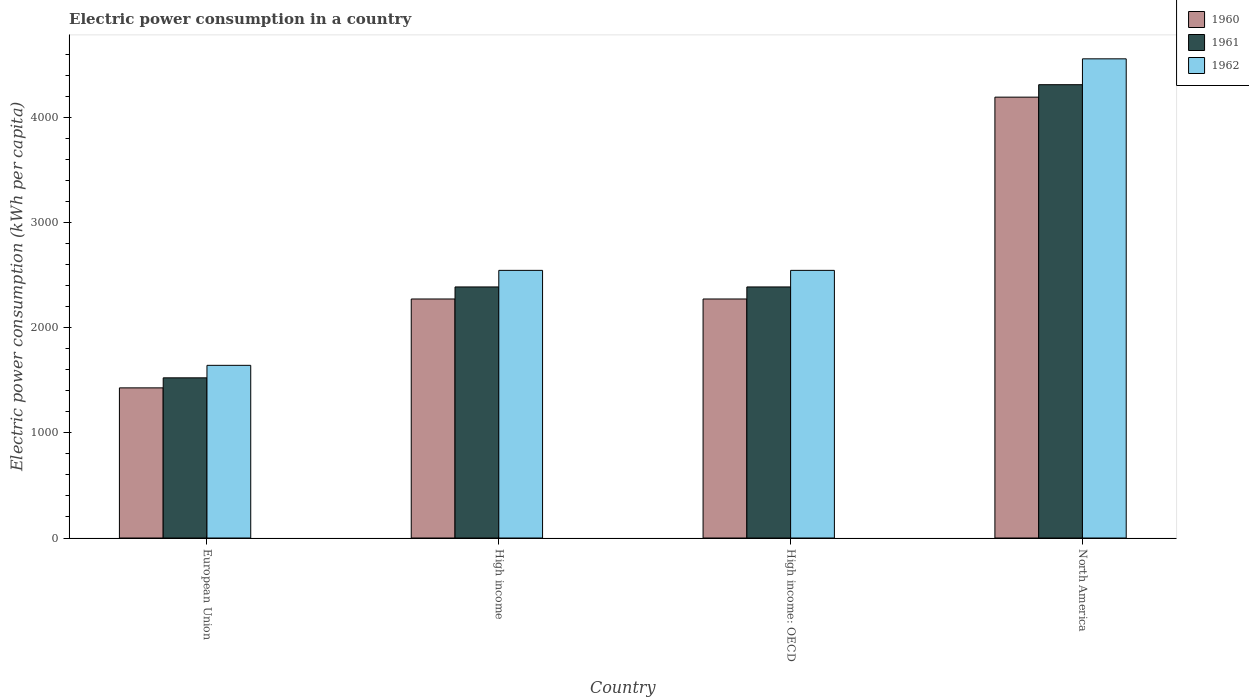Are the number of bars per tick equal to the number of legend labels?
Offer a terse response. Yes. What is the label of the 3rd group of bars from the left?
Provide a succinct answer. High income: OECD. In how many cases, is the number of bars for a given country not equal to the number of legend labels?
Provide a short and direct response. 0. What is the electric power consumption in in 1962 in European Union?
Give a very brief answer. 1641.97. Across all countries, what is the maximum electric power consumption in in 1962?
Your answer should be compact. 4556.78. Across all countries, what is the minimum electric power consumption in in 1960?
Give a very brief answer. 1427.78. In which country was the electric power consumption in in 1962 minimum?
Make the answer very short. European Union. What is the total electric power consumption in in 1961 in the graph?
Your answer should be compact. 1.06e+04. What is the difference between the electric power consumption in in 1962 in High income and that in High income: OECD?
Your answer should be compact. 0. What is the difference between the electric power consumption in in 1961 in North America and the electric power consumption in in 1962 in High income: OECD?
Provide a short and direct response. 1765.67. What is the average electric power consumption in in 1962 per country?
Make the answer very short. 2822.3. What is the difference between the electric power consumption in of/in 1961 and electric power consumption in of/in 1960 in North America?
Your answer should be very brief. 118.55. In how many countries, is the electric power consumption in in 1961 greater than 600 kWh per capita?
Give a very brief answer. 4. What is the ratio of the electric power consumption in in 1960 in European Union to that in North America?
Make the answer very short. 0.34. Is the difference between the electric power consumption in in 1961 in High income: OECD and North America greater than the difference between the electric power consumption in in 1960 in High income: OECD and North America?
Provide a short and direct response. No. What is the difference between the highest and the second highest electric power consumption in in 1962?
Offer a terse response. -2011.55. What is the difference between the highest and the lowest electric power consumption in in 1962?
Ensure brevity in your answer.  2914.81. In how many countries, is the electric power consumption in in 1960 greater than the average electric power consumption in in 1960 taken over all countries?
Your answer should be very brief. 1. Is the sum of the electric power consumption in in 1961 in High income: OECD and North America greater than the maximum electric power consumption in in 1960 across all countries?
Offer a very short reply. Yes. What does the 3rd bar from the left in European Union represents?
Provide a succinct answer. 1962. Is it the case that in every country, the sum of the electric power consumption in in 1962 and electric power consumption in in 1960 is greater than the electric power consumption in in 1961?
Offer a terse response. Yes. Are all the bars in the graph horizontal?
Offer a terse response. No. Does the graph contain any zero values?
Keep it short and to the point. No. Where does the legend appear in the graph?
Offer a very short reply. Top right. How are the legend labels stacked?
Your response must be concise. Vertical. What is the title of the graph?
Offer a terse response. Electric power consumption in a country. Does "1969" appear as one of the legend labels in the graph?
Keep it short and to the point. No. What is the label or title of the Y-axis?
Your answer should be compact. Electric power consumption (kWh per capita). What is the Electric power consumption (kWh per capita) in 1960 in European Union?
Your response must be concise. 1427.78. What is the Electric power consumption (kWh per capita) of 1961 in European Union?
Keep it short and to the point. 1523.15. What is the Electric power consumption (kWh per capita) of 1962 in European Union?
Provide a succinct answer. 1641.97. What is the Electric power consumption (kWh per capita) in 1960 in High income?
Offer a terse response. 2272.98. What is the Electric power consumption (kWh per capita) of 1961 in High income?
Give a very brief answer. 2387.51. What is the Electric power consumption (kWh per capita) in 1962 in High income?
Your answer should be compact. 2545.23. What is the Electric power consumption (kWh per capita) in 1960 in High income: OECD?
Make the answer very short. 2272.98. What is the Electric power consumption (kWh per capita) in 1961 in High income: OECD?
Your response must be concise. 2387.51. What is the Electric power consumption (kWh per capita) of 1962 in High income: OECD?
Keep it short and to the point. 2545.23. What is the Electric power consumption (kWh per capita) in 1960 in North America?
Offer a terse response. 4192.36. What is the Electric power consumption (kWh per capita) of 1961 in North America?
Provide a short and direct response. 4310.91. What is the Electric power consumption (kWh per capita) of 1962 in North America?
Offer a terse response. 4556.78. Across all countries, what is the maximum Electric power consumption (kWh per capita) in 1960?
Keep it short and to the point. 4192.36. Across all countries, what is the maximum Electric power consumption (kWh per capita) of 1961?
Provide a succinct answer. 4310.91. Across all countries, what is the maximum Electric power consumption (kWh per capita) of 1962?
Offer a terse response. 4556.78. Across all countries, what is the minimum Electric power consumption (kWh per capita) in 1960?
Offer a very short reply. 1427.78. Across all countries, what is the minimum Electric power consumption (kWh per capita) in 1961?
Provide a short and direct response. 1523.15. Across all countries, what is the minimum Electric power consumption (kWh per capita) of 1962?
Offer a terse response. 1641.97. What is the total Electric power consumption (kWh per capita) of 1960 in the graph?
Keep it short and to the point. 1.02e+04. What is the total Electric power consumption (kWh per capita) of 1961 in the graph?
Make the answer very short. 1.06e+04. What is the total Electric power consumption (kWh per capita) of 1962 in the graph?
Provide a short and direct response. 1.13e+04. What is the difference between the Electric power consumption (kWh per capita) in 1960 in European Union and that in High income?
Give a very brief answer. -845.19. What is the difference between the Electric power consumption (kWh per capita) of 1961 in European Union and that in High income?
Provide a short and direct response. -864.36. What is the difference between the Electric power consumption (kWh per capita) in 1962 in European Union and that in High income?
Your response must be concise. -903.27. What is the difference between the Electric power consumption (kWh per capita) in 1960 in European Union and that in High income: OECD?
Ensure brevity in your answer.  -845.19. What is the difference between the Electric power consumption (kWh per capita) in 1961 in European Union and that in High income: OECD?
Provide a succinct answer. -864.36. What is the difference between the Electric power consumption (kWh per capita) of 1962 in European Union and that in High income: OECD?
Provide a short and direct response. -903.27. What is the difference between the Electric power consumption (kWh per capita) in 1960 in European Union and that in North America?
Your answer should be compact. -2764.57. What is the difference between the Electric power consumption (kWh per capita) of 1961 in European Union and that in North America?
Your response must be concise. -2787.76. What is the difference between the Electric power consumption (kWh per capita) of 1962 in European Union and that in North America?
Your response must be concise. -2914.81. What is the difference between the Electric power consumption (kWh per capita) of 1960 in High income and that in High income: OECD?
Your answer should be compact. 0. What is the difference between the Electric power consumption (kWh per capita) of 1962 in High income and that in High income: OECD?
Offer a very short reply. 0. What is the difference between the Electric power consumption (kWh per capita) in 1960 in High income and that in North America?
Your answer should be compact. -1919.38. What is the difference between the Electric power consumption (kWh per capita) of 1961 in High income and that in North America?
Your response must be concise. -1923.4. What is the difference between the Electric power consumption (kWh per capita) of 1962 in High income and that in North America?
Your answer should be compact. -2011.55. What is the difference between the Electric power consumption (kWh per capita) in 1960 in High income: OECD and that in North America?
Your response must be concise. -1919.38. What is the difference between the Electric power consumption (kWh per capita) of 1961 in High income: OECD and that in North America?
Provide a short and direct response. -1923.4. What is the difference between the Electric power consumption (kWh per capita) in 1962 in High income: OECD and that in North America?
Your answer should be very brief. -2011.55. What is the difference between the Electric power consumption (kWh per capita) in 1960 in European Union and the Electric power consumption (kWh per capita) in 1961 in High income?
Provide a succinct answer. -959.72. What is the difference between the Electric power consumption (kWh per capita) in 1960 in European Union and the Electric power consumption (kWh per capita) in 1962 in High income?
Make the answer very short. -1117.45. What is the difference between the Electric power consumption (kWh per capita) in 1961 in European Union and the Electric power consumption (kWh per capita) in 1962 in High income?
Your response must be concise. -1022.08. What is the difference between the Electric power consumption (kWh per capita) in 1960 in European Union and the Electric power consumption (kWh per capita) in 1961 in High income: OECD?
Your answer should be compact. -959.72. What is the difference between the Electric power consumption (kWh per capita) of 1960 in European Union and the Electric power consumption (kWh per capita) of 1962 in High income: OECD?
Ensure brevity in your answer.  -1117.45. What is the difference between the Electric power consumption (kWh per capita) of 1961 in European Union and the Electric power consumption (kWh per capita) of 1962 in High income: OECD?
Provide a succinct answer. -1022.08. What is the difference between the Electric power consumption (kWh per capita) in 1960 in European Union and the Electric power consumption (kWh per capita) in 1961 in North America?
Give a very brief answer. -2883.12. What is the difference between the Electric power consumption (kWh per capita) of 1960 in European Union and the Electric power consumption (kWh per capita) of 1962 in North America?
Your answer should be compact. -3128.99. What is the difference between the Electric power consumption (kWh per capita) in 1961 in European Union and the Electric power consumption (kWh per capita) in 1962 in North America?
Offer a terse response. -3033.63. What is the difference between the Electric power consumption (kWh per capita) in 1960 in High income and the Electric power consumption (kWh per capita) in 1961 in High income: OECD?
Your answer should be compact. -114.53. What is the difference between the Electric power consumption (kWh per capita) of 1960 in High income and the Electric power consumption (kWh per capita) of 1962 in High income: OECD?
Make the answer very short. -272.26. What is the difference between the Electric power consumption (kWh per capita) in 1961 in High income and the Electric power consumption (kWh per capita) in 1962 in High income: OECD?
Give a very brief answer. -157.73. What is the difference between the Electric power consumption (kWh per capita) of 1960 in High income and the Electric power consumption (kWh per capita) of 1961 in North America?
Provide a succinct answer. -2037.93. What is the difference between the Electric power consumption (kWh per capita) of 1960 in High income and the Electric power consumption (kWh per capita) of 1962 in North America?
Offer a terse response. -2283.8. What is the difference between the Electric power consumption (kWh per capita) of 1961 in High income and the Electric power consumption (kWh per capita) of 1962 in North America?
Your answer should be very brief. -2169.27. What is the difference between the Electric power consumption (kWh per capita) of 1960 in High income: OECD and the Electric power consumption (kWh per capita) of 1961 in North America?
Your response must be concise. -2037.93. What is the difference between the Electric power consumption (kWh per capita) in 1960 in High income: OECD and the Electric power consumption (kWh per capita) in 1962 in North America?
Offer a very short reply. -2283.8. What is the difference between the Electric power consumption (kWh per capita) of 1961 in High income: OECD and the Electric power consumption (kWh per capita) of 1962 in North America?
Your answer should be very brief. -2169.27. What is the average Electric power consumption (kWh per capita) in 1960 per country?
Provide a short and direct response. 2541.52. What is the average Electric power consumption (kWh per capita) in 1961 per country?
Provide a short and direct response. 2652.27. What is the average Electric power consumption (kWh per capita) in 1962 per country?
Give a very brief answer. 2822.3. What is the difference between the Electric power consumption (kWh per capita) of 1960 and Electric power consumption (kWh per capita) of 1961 in European Union?
Your answer should be very brief. -95.37. What is the difference between the Electric power consumption (kWh per capita) in 1960 and Electric power consumption (kWh per capita) in 1962 in European Union?
Offer a terse response. -214.18. What is the difference between the Electric power consumption (kWh per capita) of 1961 and Electric power consumption (kWh per capita) of 1962 in European Union?
Your answer should be very brief. -118.82. What is the difference between the Electric power consumption (kWh per capita) of 1960 and Electric power consumption (kWh per capita) of 1961 in High income?
Provide a short and direct response. -114.53. What is the difference between the Electric power consumption (kWh per capita) of 1960 and Electric power consumption (kWh per capita) of 1962 in High income?
Provide a succinct answer. -272.26. What is the difference between the Electric power consumption (kWh per capita) in 1961 and Electric power consumption (kWh per capita) in 1962 in High income?
Provide a succinct answer. -157.73. What is the difference between the Electric power consumption (kWh per capita) in 1960 and Electric power consumption (kWh per capita) in 1961 in High income: OECD?
Give a very brief answer. -114.53. What is the difference between the Electric power consumption (kWh per capita) of 1960 and Electric power consumption (kWh per capita) of 1962 in High income: OECD?
Provide a succinct answer. -272.26. What is the difference between the Electric power consumption (kWh per capita) in 1961 and Electric power consumption (kWh per capita) in 1962 in High income: OECD?
Offer a terse response. -157.73. What is the difference between the Electric power consumption (kWh per capita) in 1960 and Electric power consumption (kWh per capita) in 1961 in North America?
Offer a terse response. -118.55. What is the difference between the Electric power consumption (kWh per capita) in 1960 and Electric power consumption (kWh per capita) in 1962 in North America?
Provide a succinct answer. -364.42. What is the difference between the Electric power consumption (kWh per capita) in 1961 and Electric power consumption (kWh per capita) in 1962 in North America?
Your response must be concise. -245.87. What is the ratio of the Electric power consumption (kWh per capita) of 1960 in European Union to that in High income?
Provide a succinct answer. 0.63. What is the ratio of the Electric power consumption (kWh per capita) in 1961 in European Union to that in High income?
Ensure brevity in your answer.  0.64. What is the ratio of the Electric power consumption (kWh per capita) in 1962 in European Union to that in High income?
Ensure brevity in your answer.  0.65. What is the ratio of the Electric power consumption (kWh per capita) in 1960 in European Union to that in High income: OECD?
Provide a succinct answer. 0.63. What is the ratio of the Electric power consumption (kWh per capita) in 1961 in European Union to that in High income: OECD?
Your answer should be compact. 0.64. What is the ratio of the Electric power consumption (kWh per capita) in 1962 in European Union to that in High income: OECD?
Provide a succinct answer. 0.65. What is the ratio of the Electric power consumption (kWh per capita) of 1960 in European Union to that in North America?
Your answer should be compact. 0.34. What is the ratio of the Electric power consumption (kWh per capita) of 1961 in European Union to that in North America?
Give a very brief answer. 0.35. What is the ratio of the Electric power consumption (kWh per capita) of 1962 in European Union to that in North America?
Ensure brevity in your answer.  0.36. What is the ratio of the Electric power consumption (kWh per capita) of 1961 in High income to that in High income: OECD?
Offer a very short reply. 1. What is the ratio of the Electric power consumption (kWh per capita) of 1962 in High income to that in High income: OECD?
Your answer should be very brief. 1. What is the ratio of the Electric power consumption (kWh per capita) of 1960 in High income to that in North America?
Ensure brevity in your answer.  0.54. What is the ratio of the Electric power consumption (kWh per capita) of 1961 in High income to that in North America?
Provide a short and direct response. 0.55. What is the ratio of the Electric power consumption (kWh per capita) in 1962 in High income to that in North America?
Offer a very short reply. 0.56. What is the ratio of the Electric power consumption (kWh per capita) in 1960 in High income: OECD to that in North America?
Keep it short and to the point. 0.54. What is the ratio of the Electric power consumption (kWh per capita) in 1961 in High income: OECD to that in North America?
Provide a short and direct response. 0.55. What is the ratio of the Electric power consumption (kWh per capita) in 1962 in High income: OECD to that in North America?
Your answer should be compact. 0.56. What is the difference between the highest and the second highest Electric power consumption (kWh per capita) in 1960?
Provide a succinct answer. 1919.38. What is the difference between the highest and the second highest Electric power consumption (kWh per capita) of 1961?
Your answer should be compact. 1923.4. What is the difference between the highest and the second highest Electric power consumption (kWh per capita) in 1962?
Give a very brief answer. 2011.55. What is the difference between the highest and the lowest Electric power consumption (kWh per capita) in 1960?
Your answer should be compact. 2764.57. What is the difference between the highest and the lowest Electric power consumption (kWh per capita) of 1961?
Your response must be concise. 2787.76. What is the difference between the highest and the lowest Electric power consumption (kWh per capita) in 1962?
Offer a very short reply. 2914.81. 